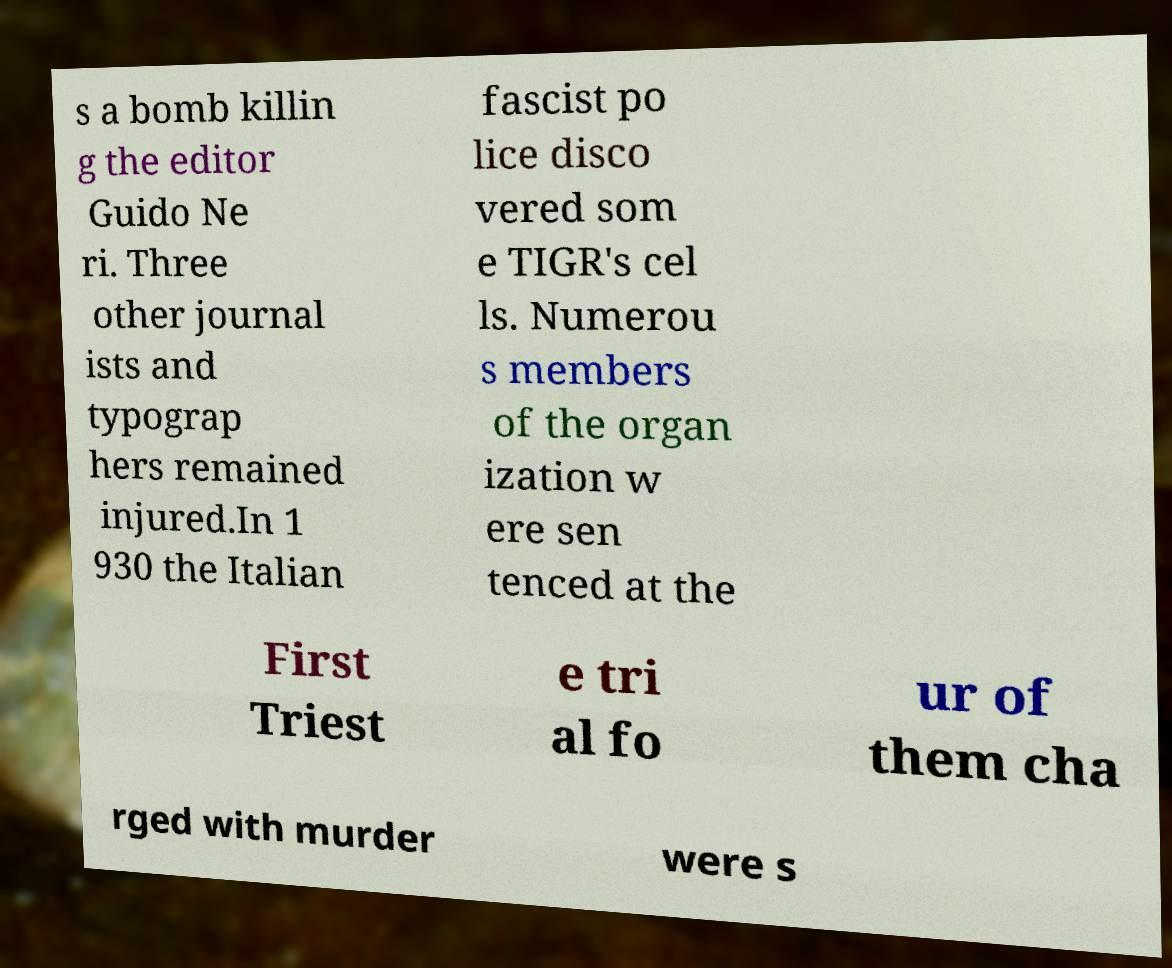Can you accurately transcribe the text from the provided image for me? s a bomb killin g the editor Guido Ne ri. Three other journal ists and typograp hers remained injured.In 1 930 the Italian fascist po lice disco vered som e TIGR's cel ls. Numerou s members of the organ ization w ere sen tenced at the First Triest e tri al fo ur of them cha rged with murder were s 